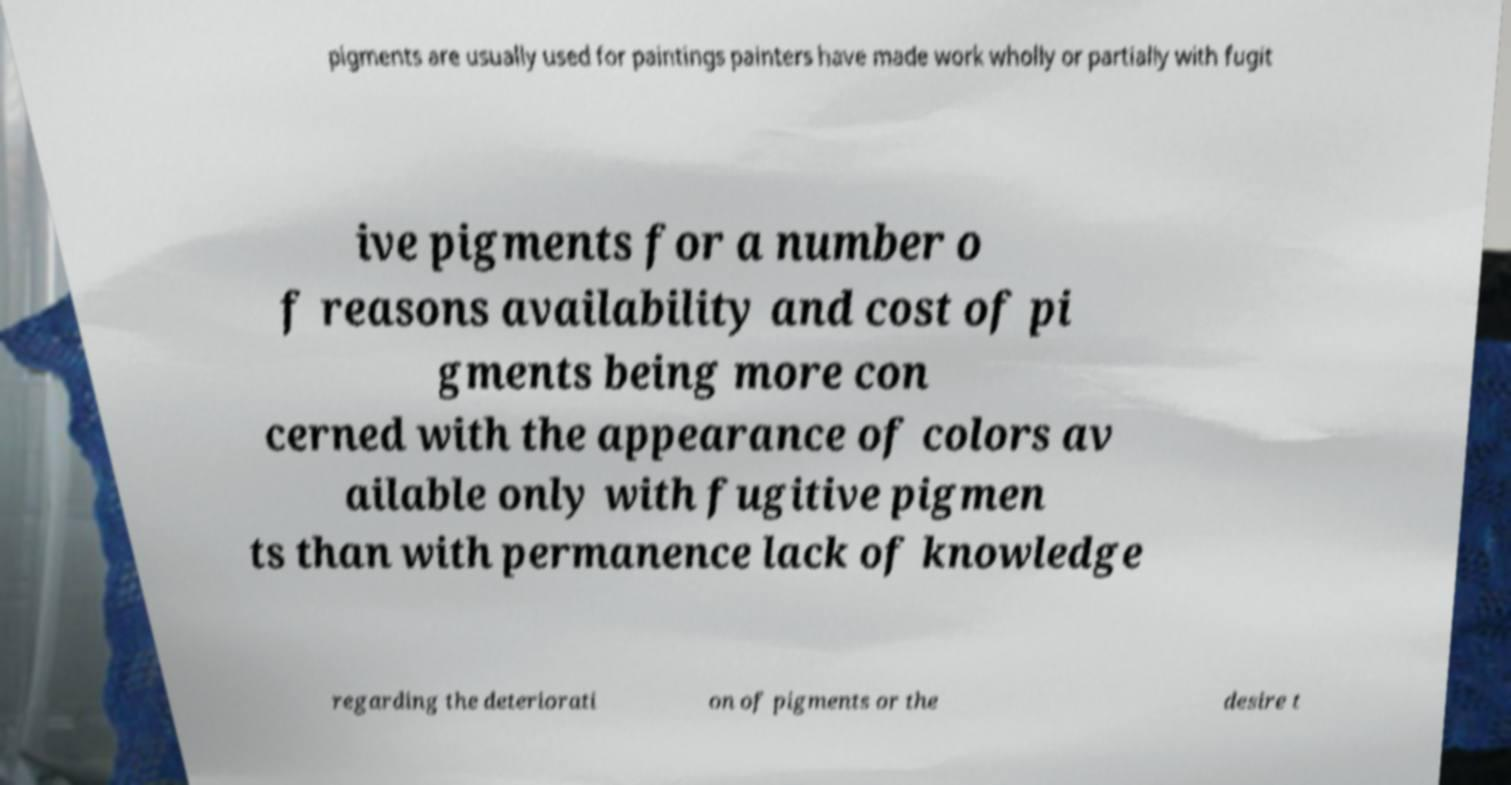Please identify and transcribe the text found in this image. pigments are usually used for paintings painters have made work wholly or partially with fugit ive pigments for a number o f reasons availability and cost of pi gments being more con cerned with the appearance of colors av ailable only with fugitive pigmen ts than with permanence lack of knowledge regarding the deteriorati on of pigments or the desire t 